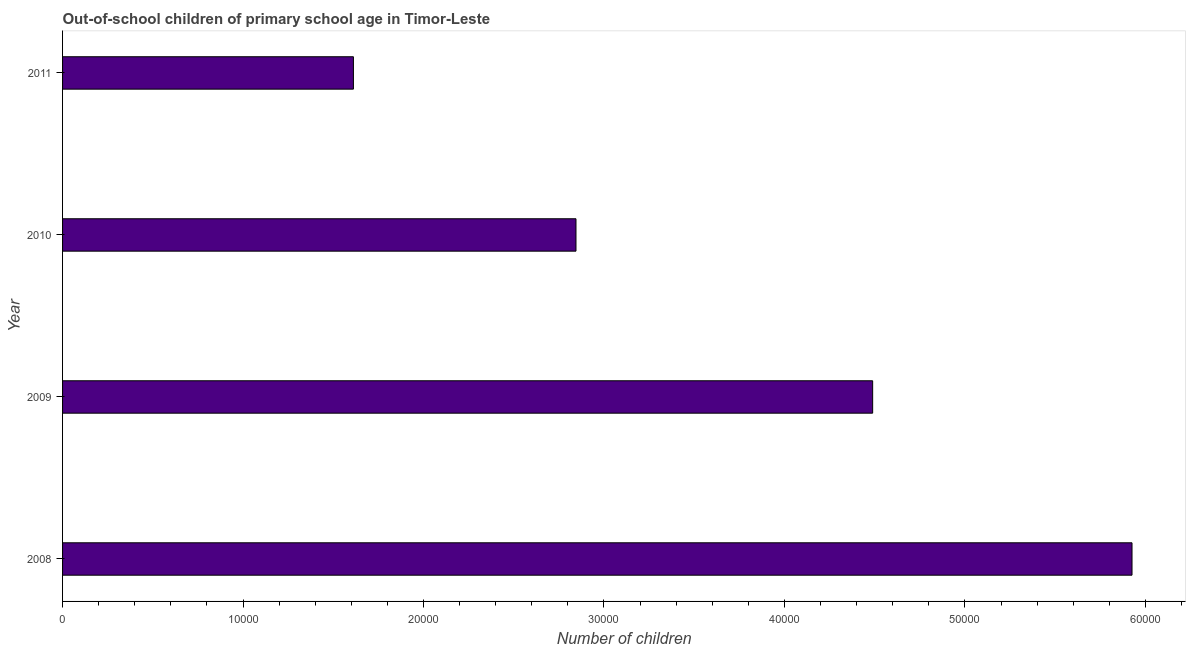What is the title of the graph?
Offer a very short reply. Out-of-school children of primary school age in Timor-Leste. What is the label or title of the X-axis?
Make the answer very short. Number of children. What is the number of out-of-school children in 2010?
Keep it short and to the point. 2.84e+04. Across all years, what is the maximum number of out-of-school children?
Ensure brevity in your answer.  5.93e+04. Across all years, what is the minimum number of out-of-school children?
Give a very brief answer. 1.61e+04. In which year was the number of out-of-school children maximum?
Make the answer very short. 2008. In which year was the number of out-of-school children minimum?
Your answer should be very brief. 2011. What is the sum of the number of out-of-school children?
Provide a succinct answer. 1.49e+05. What is the difference between the number of out-of-school children in 2009 and 2010?
Provide a short and direct response. 1.64e+04. What is the average number of out-of-school children per year?
Your response must be concise. 3.72e+04. What is the median number of out-of-school children?
Offer a terse response. 3.67e+04. In how many years, is the number of out-of-school children greater than 56000 ?
Your answer should be very brief. 1. What is the ratio of the number of out-of-school children in 2008 to that in 2010?
Your response must be concise. 2.08. Is the number of out-of-school children in 2008 less than that in 2010?
Your response must be concise. No. What is the difference between the highest and the second highest number of out-of-school children?
Provide a short and direct response. 1.44e+04. What is the difference between the highest and the lowest number of out-of-school children?
Offer a very short reply. 4.31e+04. In how many years, is the number of out-of-school children greater than the average number of out-of-school children taken over all years?
Ensure brevity in your answer.  2. How many years are there in the graph?
Keep it short and to the point. 4. Are the values on the major ticks of X-axis written in scientific E-notation?
Offer a terse response. No. What is the Number of children in 2008?
Keep it short and to the point. 5.93e+04. What is the Number of children in 2009?
Provide a short and direct response. 4.49e+04. What is the Number of children in 2010?
Your response must be concise. 2.84e+04. What is the Number of children in 2011?
Keep it short and to the point. 1.61e+04. What is the difference between the Number of children in 2008 and 2009?
Your answer should be compact. 1.44e+04. What is the difference between the Number of children in 2008 and 2010?
Make the answer very short. 3.08e+04. What is the difference between the Number of children in 2008 and 2011?
Offer a terse response. 4.31e+04. What is the difference between the Number of children in 2009 and 2010?
Offer a very short reply. 1.64e+04. What is the difference between the Number of children in 2009 and 2011?
Provide a short and direct response. 2.88e+04. What is the difference between the Number of children in 2010 and 2011?
Your answer should be compact. 1.23e+04. What is the ratio of the Number of children in 2008 to that in 2009?
Offer a very short reply. 1.32. What is the ratio of the Number of children in 2008 to that in 2010?
Your response must be concise. 2.08. What is the ratio of the Number of children in 2008 to that in 2011?
Your response must be concise. 3.68. What is the ratio of the Number of children in 2009 to that in 2010?
Ensure brevity in your answer.  1.58. What is the ratio of the Number of children in 2009 to that in 2011?
Ensure brevity in your answer.  2.79. What is the ratio of the Number of children in 2010 to that in 2011?
Give a very brief answer. 1.76. 